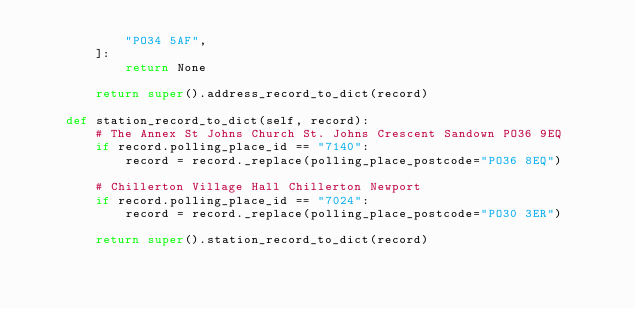Convert code to text. <code><loc_0><loc_0><loc_500><loc_500><_Python_>            "PO34 5AF",
        ]:
            return None

        return super().address_record_to_dict(record)

    def station_record_to_dict(self, record):
        # The Annex St Johns Church St. Johns Crescent Sandown PO36 9EQ
        if record.polling_place_id == "7140":
            record = record._replace(polling_place_postcode="PO36 8EQ")

        # Chillerton Village Hall Chillerton Newport
        if record.polling_place_id == "7024":
            record = record._replace(polling_place_postcode="PO30 3ER")

        return super().station_record_to_dict(record)
</code> 